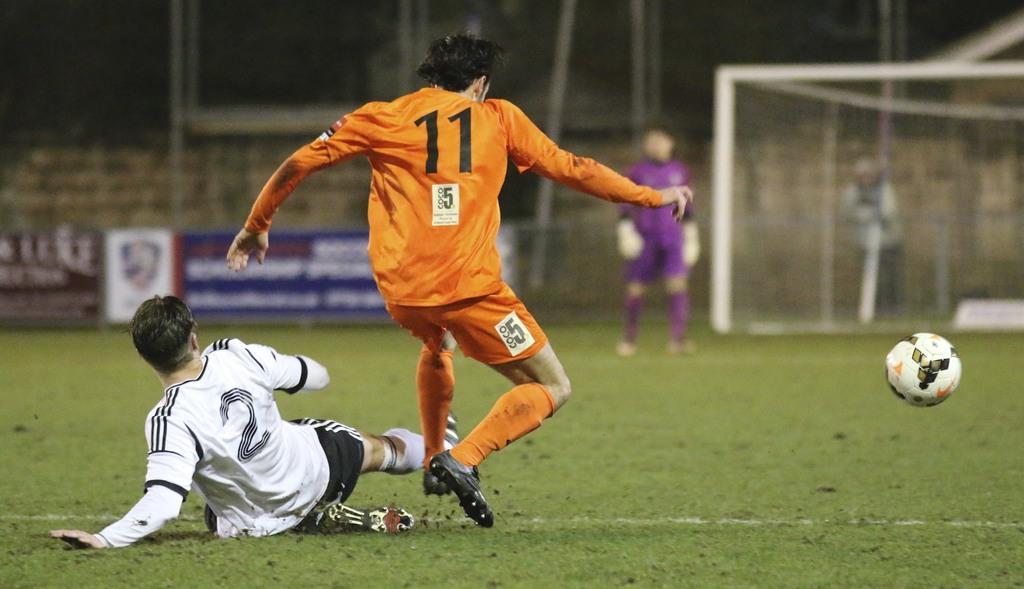Can you describe this image briefly? In this image we can see the players present in the playground. We can also see the ball, banners with text, fencing wall and also the net. 